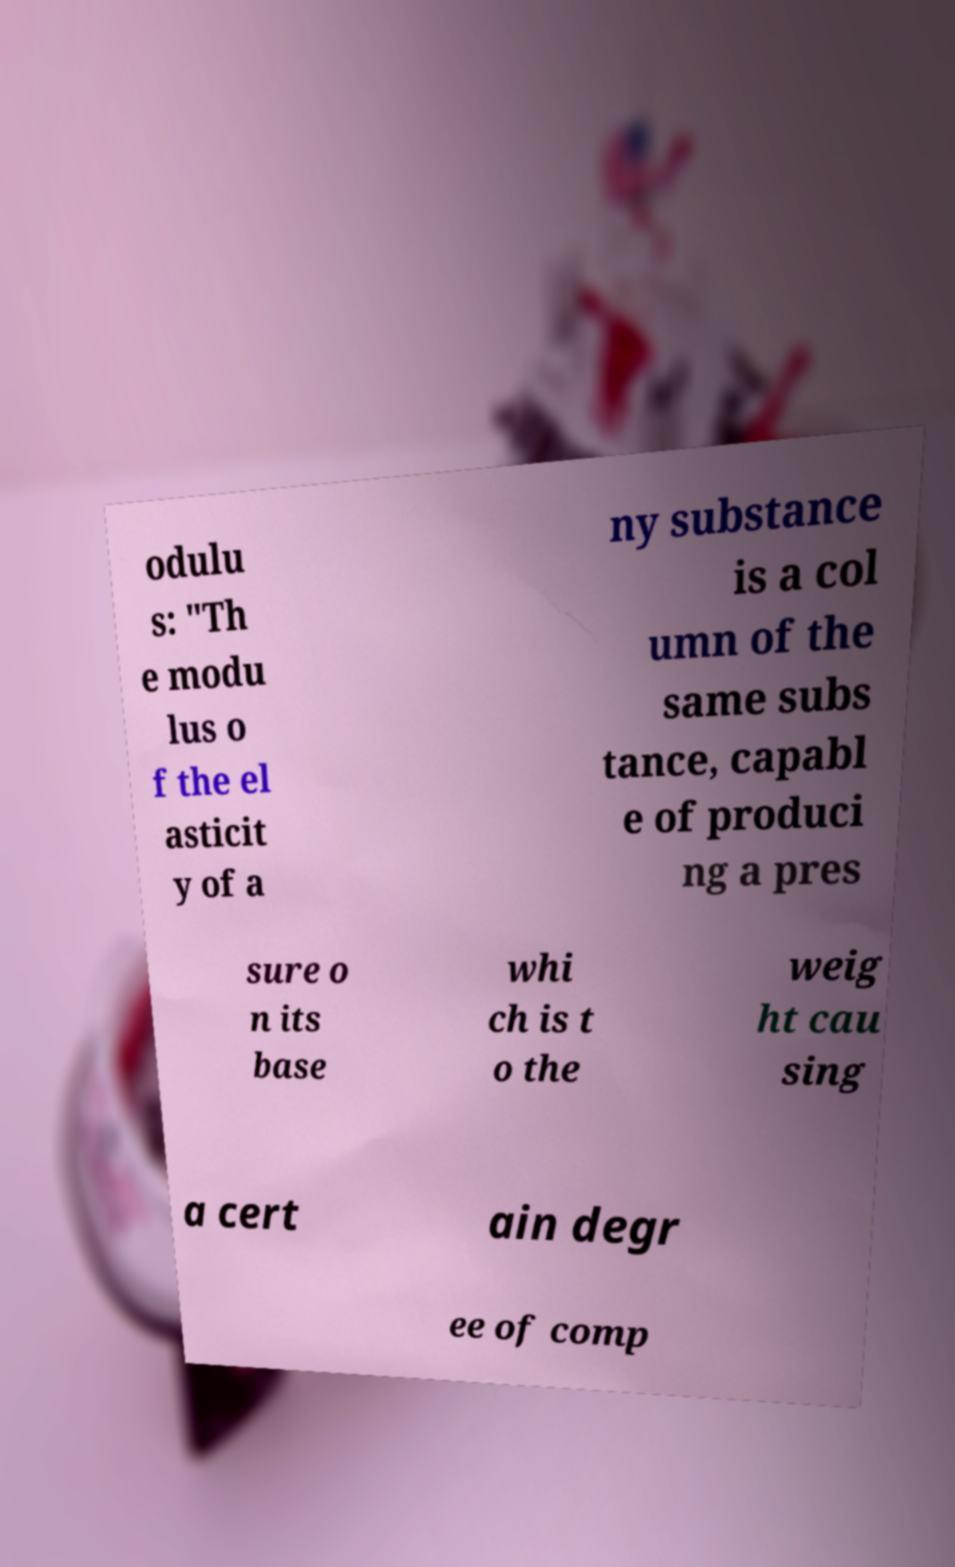Can you accurately transcribe the text from the provided image for me? odulu s: "Th e modu lus o f the el asticit y of a ny substance is a col umn of the same subs tance, capabl e of produci ng a pres sure o n its base whi ch is t o the weig ht cau sing a cert ain degr ee of comp 